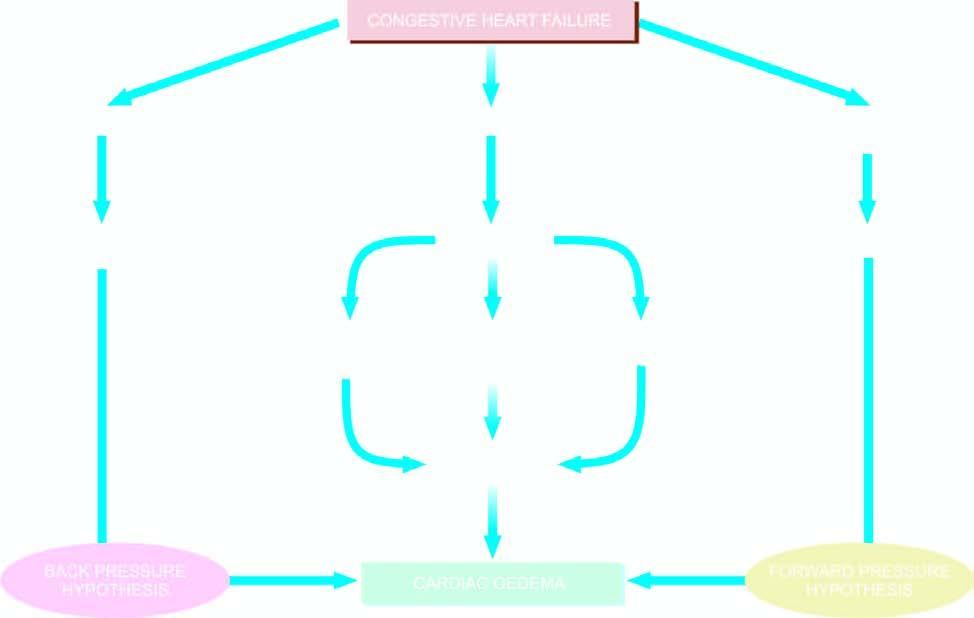s mechanisms involved in the pathogenesis of cardiac oedema?
Answer the question using a single word or phrase. Yes 